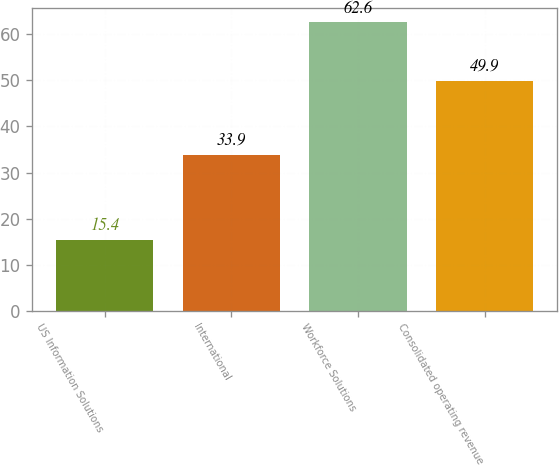Convert chart. <chart><loc_0><loc_0><loc_500><loc_500><bar_chart><fcel>US Information Solutions<fcel>International<fcel>Workforce Solutions<fcel>Consolidated operating revenue<nl><fcel>15.4<fcel>33.9<fcel>62.6<fcel>49.9<nl></chart> 